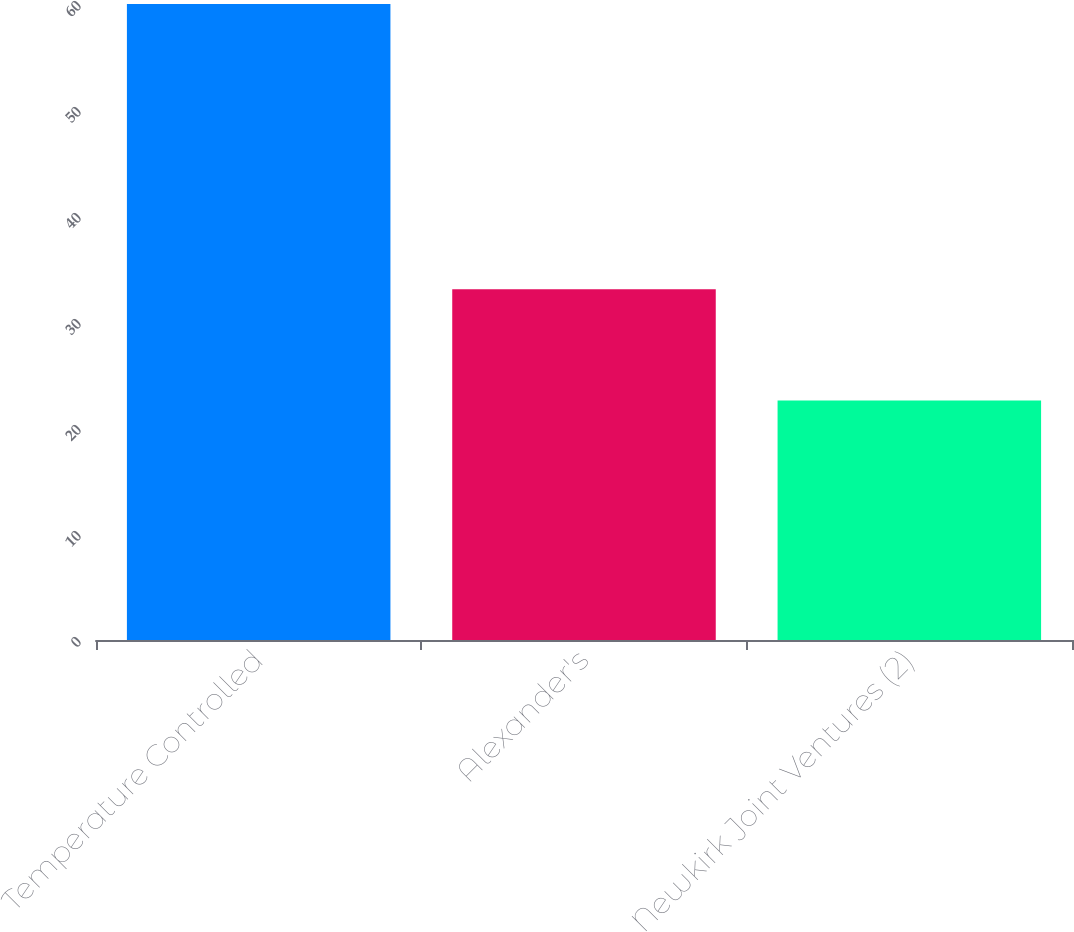<chart> <loc_0><loc_0><loc_500><loc_500><bar_chart><fcel>Temperature Controlled<fcel>Alexander's<fcel>Newkirk Joint Ventures (2)<nl><fcel>60<fcel>33.1<fcel>22.6<nl></chart> 